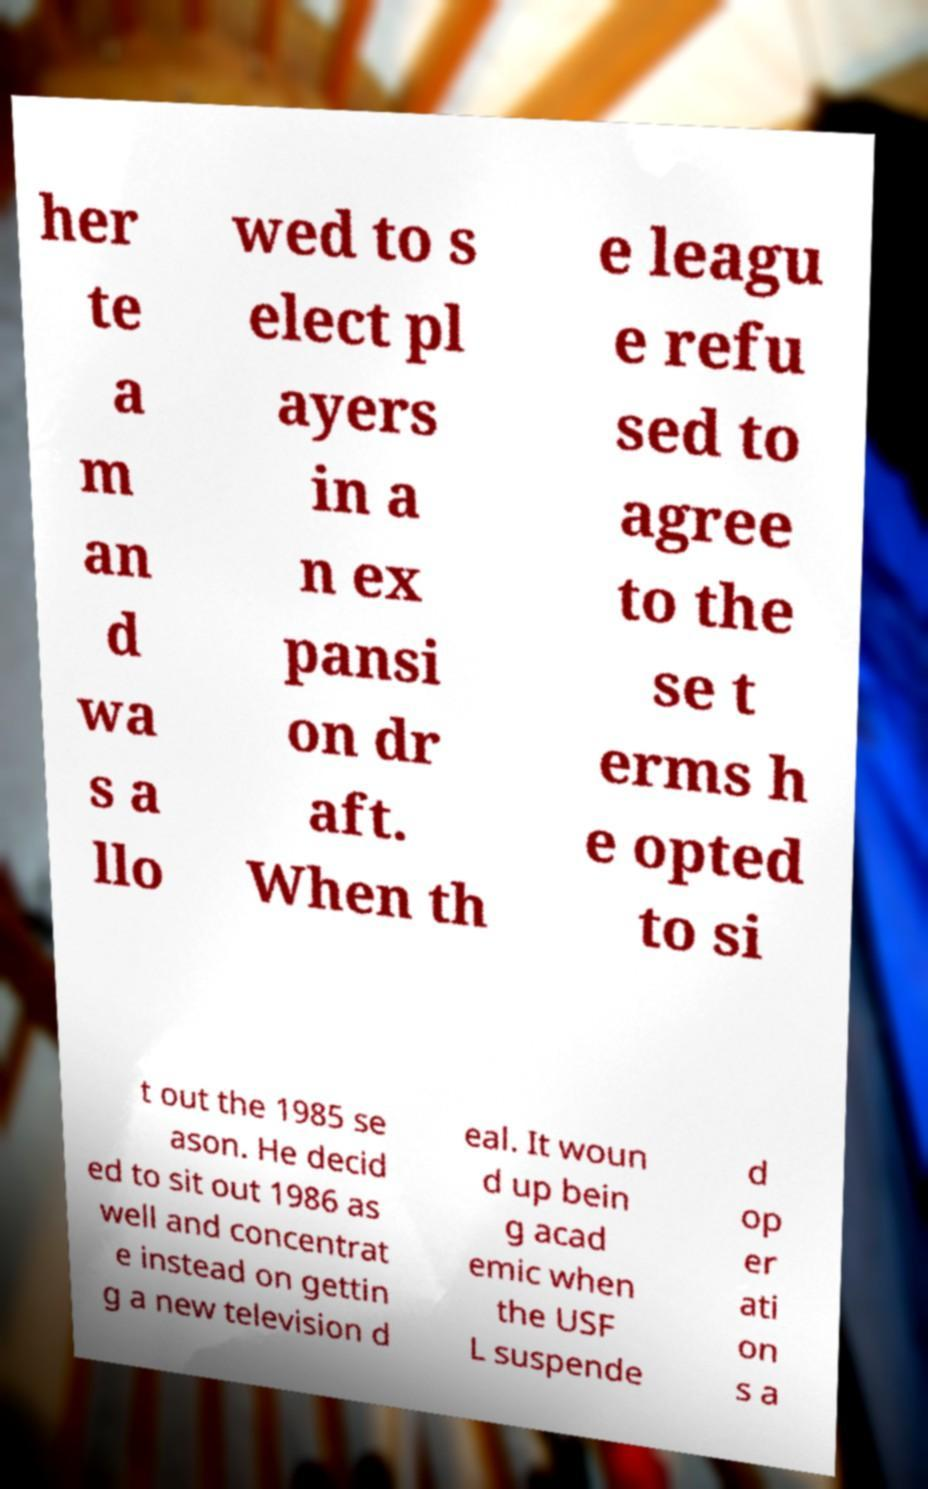I need the written content from this picture converted into text. Can you do that? her te a m an d wa s a llo wed to s elect pl ayers in a n ex pansi on dr aft. When th e leagu e refu sed to agree to the se t erms h e opted to si t out the 1985 se ason. He decid ed to sit out 1986 as well and concentrat e instead on gettin g a new television d eal. It woun d up bein g acad emic when the USF L suspende d op er ati on s a 